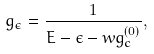<formula> <loc_0><loc_0><loc_500><loc_500>g _ { \epsilon } = \frac { 1 } { E - \epsilon - w g _ { c } ^ { ( 0 ) } } ,</formula> 